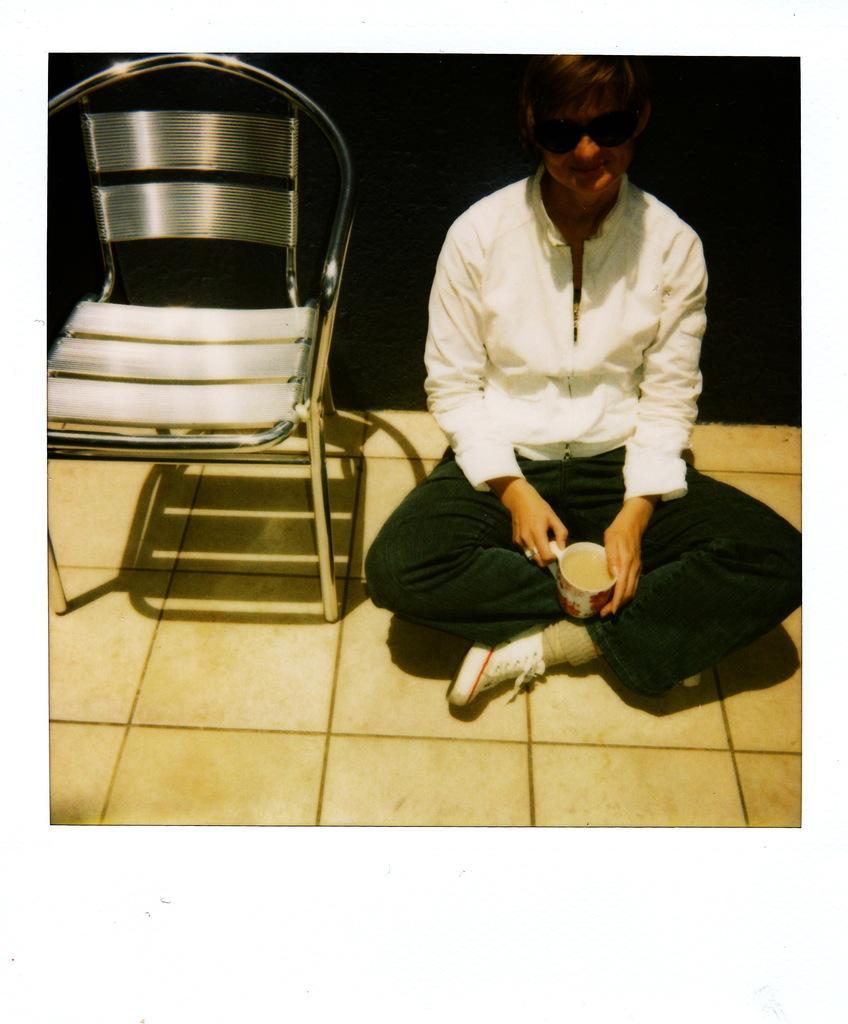Could you give a brief overview of what you see in this image? In this picture we can see a person sitting on the floor, he is holding a cup, beside to him we can see a chair and in the background we can see it is dark. 